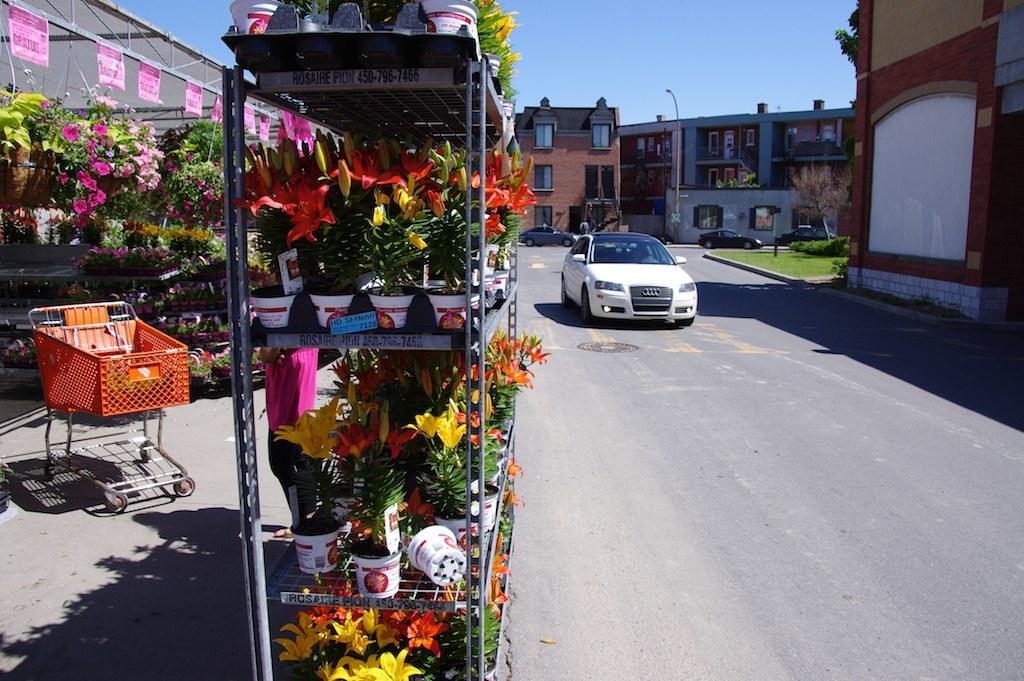In one or two sentences, can you explain what this image depicts? In the image we can see there is a florist store and there are cars parked on the road. Behind there are buildings. 